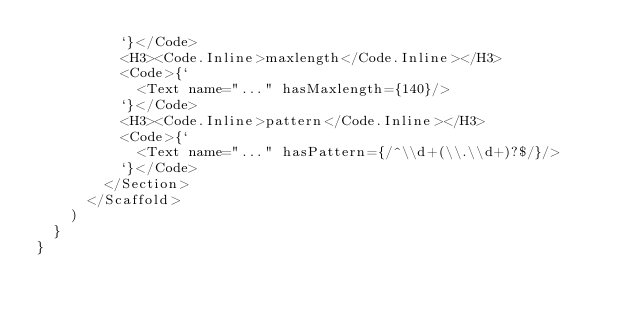Convert code to text. <code><loc_0><loc_0><loc_500><loc_500><_JavaScript_>          `}</Code>
          <H3><Code.Inline>maxlength</Code.Inline></H3>
          <Code>{`
            <Text name="..." hasMaxlength={140}/>
          `}</Code>
          <H3><Code.Inline>pattern</Code.Inline></H3>
          <Code>{`
            <Text name="..." hasPattern={/^\\d+(\\.\\d+)?$/}/>
          `}</Code>
        </Section>
      </Scaffold>
    )
  }
}
</code> 